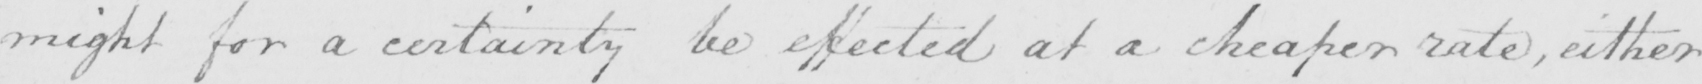Transcribe the text shown in this historical manuscript line. might for a certainty be effected at a cheaper rate , either 